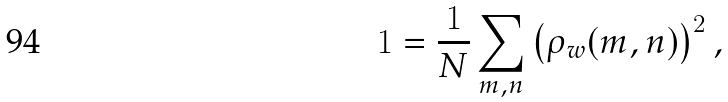<formula> <loc_0><loc_0><loc_500><loc_500>1 = \frac { 1 } { N } \sum _ { m , n } \left ( \rho _ { w } ( m , n ) \right ) ^ { 2 } ,</formula> 